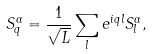<formula> <loc_0><loc_0><loc_500><loc_500>S ^ { \alpha } _ { q } = \frac { 1 } { \sqrt { L } } \sum _ { l } e ^ { i q l } S ^ { \alpha } _ { l } ,</formula> 